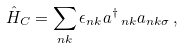Convert formula to latex. <formula><loc_0><loc_0><loc_500><loc_500>\hat { H } _ { C } = \sum _ { n k } \epsilon _ { n k } { a ^ { \dagger } } _ { \, n k } a _ { n k \sigma } \, ,</formula> 